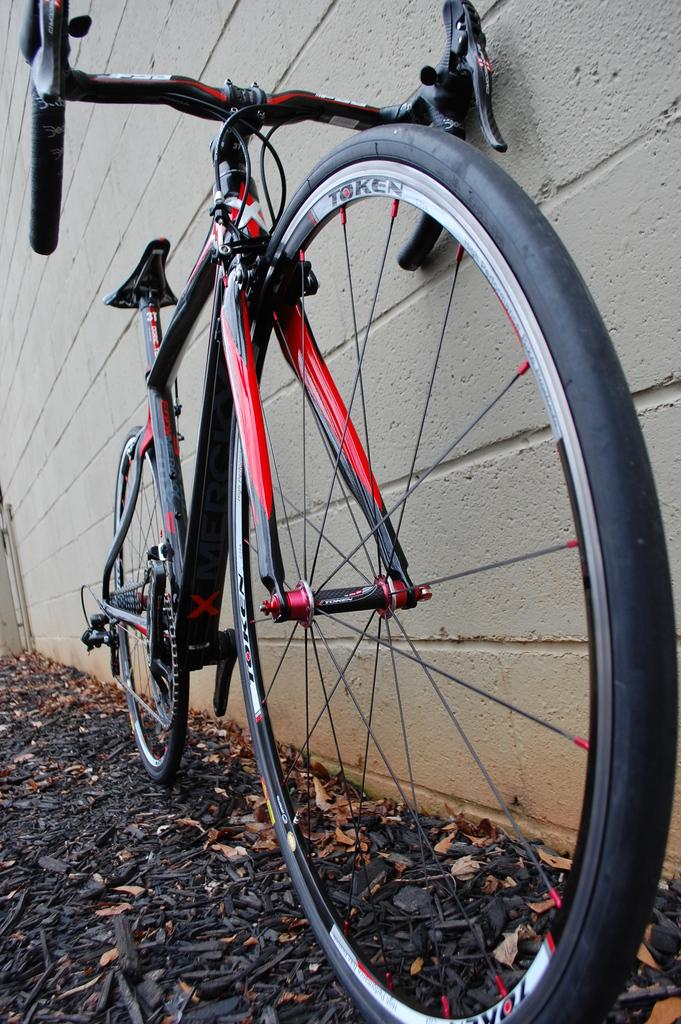What is the main object in the image? There is a bicycle in the image. Where is the bicycle located in relation to other objects? The bicycle is parked near a wall. What can be seen on the ground in the image? Dry leaves are present on the ground in the image. How many seats are available on the bicycle in the image? There is no mention of seats on the bicycle in the image, so it is impossible to determine the number of available seats. 